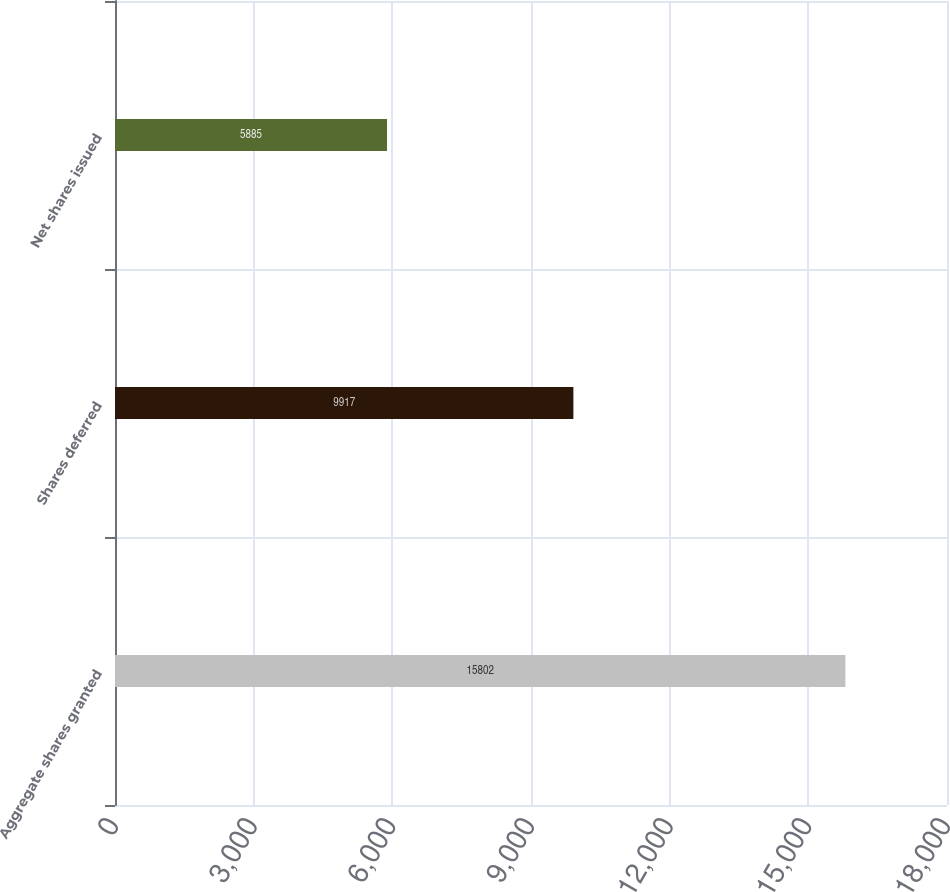Convert chart. <chart><loc_0><loc_0><loc_500><loc_500><bar_chart><fcel>Aggregate shares granted<fcel>Shares deferred<fcel>Net shares issued<nl><fcel>15802<fcel>9917<fcel>5885<nl></chart> 